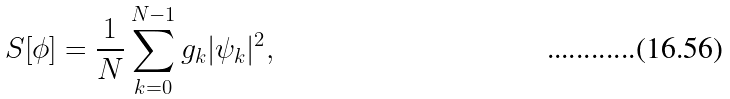Convert formula to latex. <formula><loc_0><loc_0><loc_500><loc_500>S [ \phi ] = \frac { 1 } { N } \sum _ { k = 0 } ^ { N - 1 } g _ { k } | \psi _ { k } | ^ { 2 } ,</formula> 